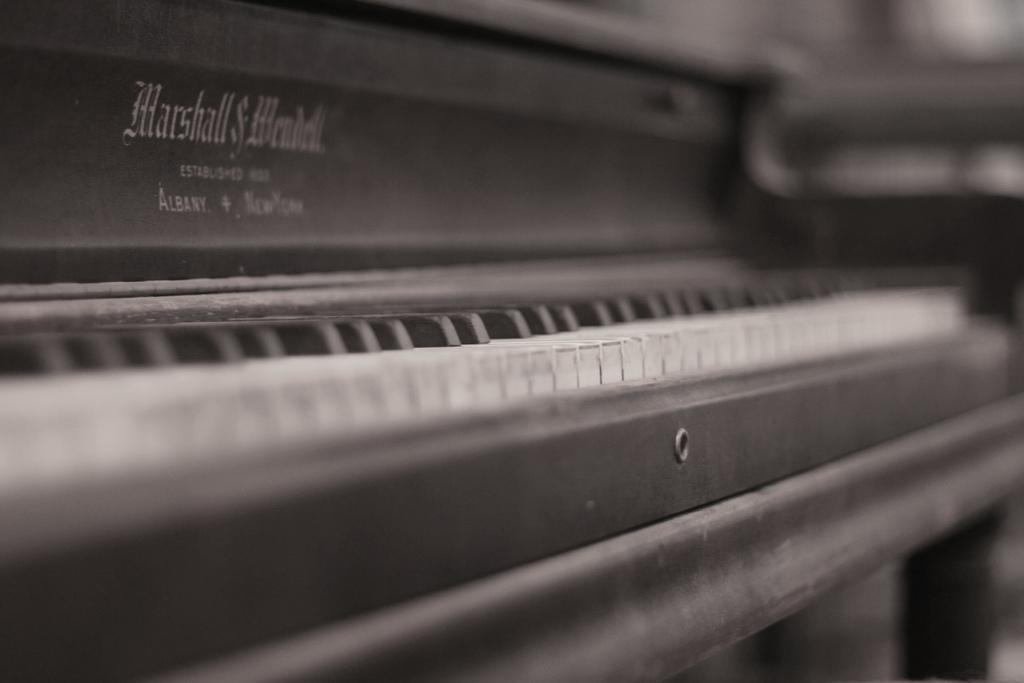What is the main object in the image? There is a piano in the image. What can be seen on the piano? There is text printed on the piano. How does the belief system of the person playing the piano affect the sound produced? There is no indication of a person playing the piano or any belief system in the image, so it cannot be determined how it might affect the sound produced. 